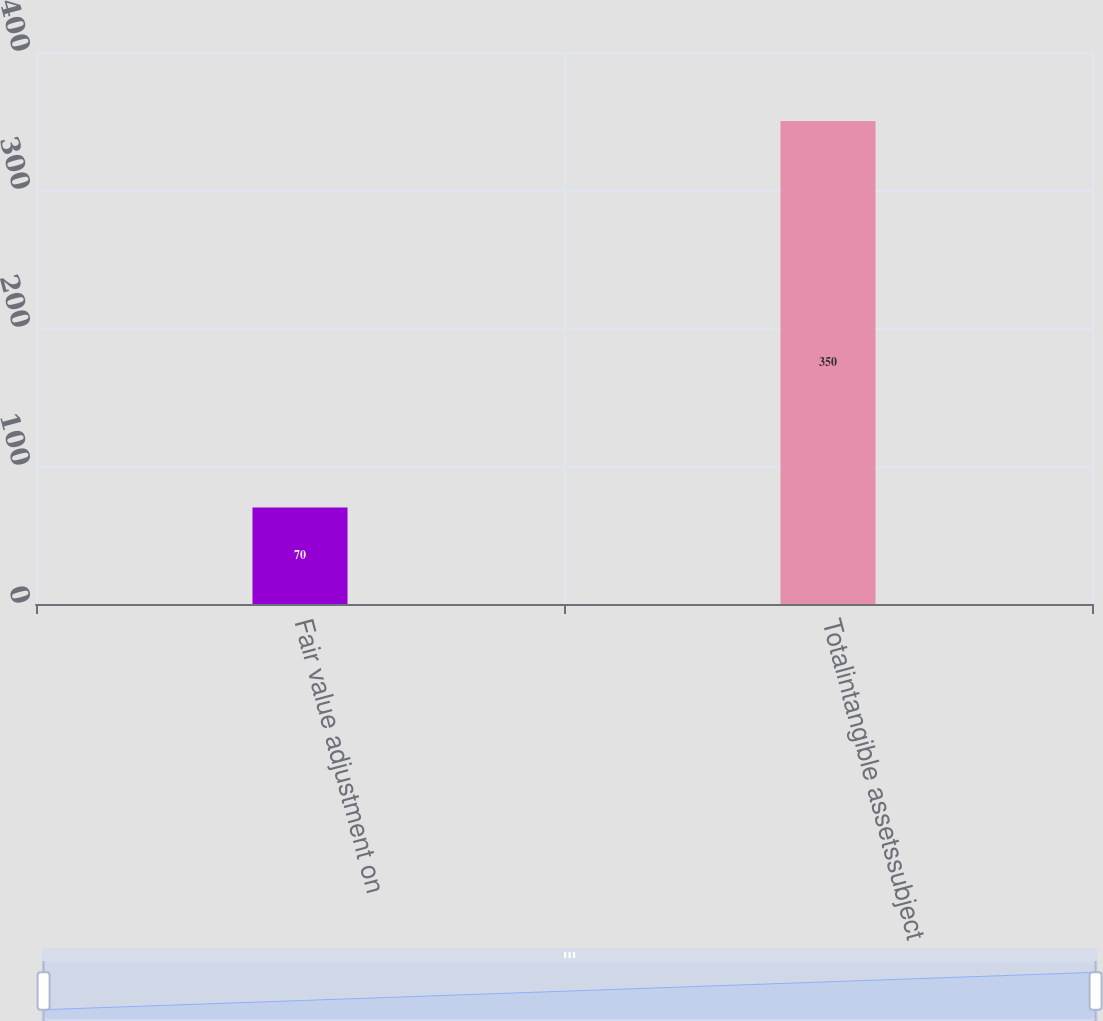<chart> <loc_0><loc_0><loc_500><loc_500><bar_chart><fcel>Fair value adjustment on<fcel>Totalintangible assetssubject<nl><fcel>70<fcel>350<nl></chart> 